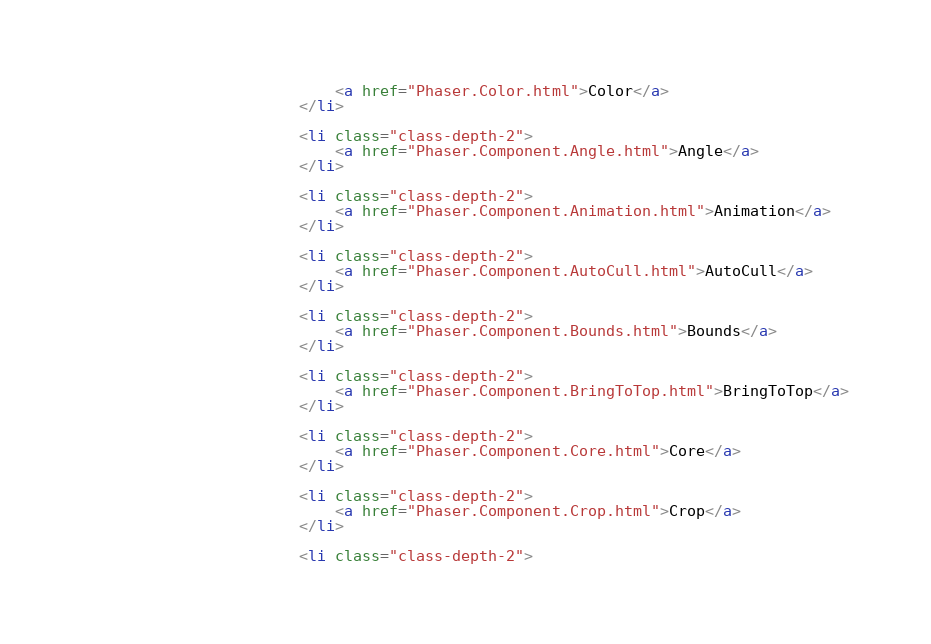<code> <loc_0><loc_0><loc_500><loc_500><_HTML_>							<a href="Phaser.Color.html">Color</a>
						</li>
						
						<li class="class-depth-2">
							<a href="Phaser.Component.Angle.html">Angle</a>
						</li>
						
						<li class="class-depth-2">
							<a href="Phaser.Component.Animation.html">Animation</a>
						</li>
						
						<li class="class-depth-2">
							<a href="Phaser.Component.AutoCull.html">AutoCull</a>
						</li>
						
						<li class="class-depth-2">
							<a href="Phaser.Component.Bounds.html">Bounds</a>
						</li>
						
						<li class="class-depth-2">
							<a href="Phaser.Component.BringToTop.html">BringToTop</a>
						</li>
						
						<li class="class-depth-2">
							<a href="Phaser.Component.Core.html">Core</a>
						</li>
						
						<li class="class-depth-2">
							<a href="Phaser.Component.Crop.html">Crop</a>
						</li>
						
						<li class="class-depth-2"></code> 